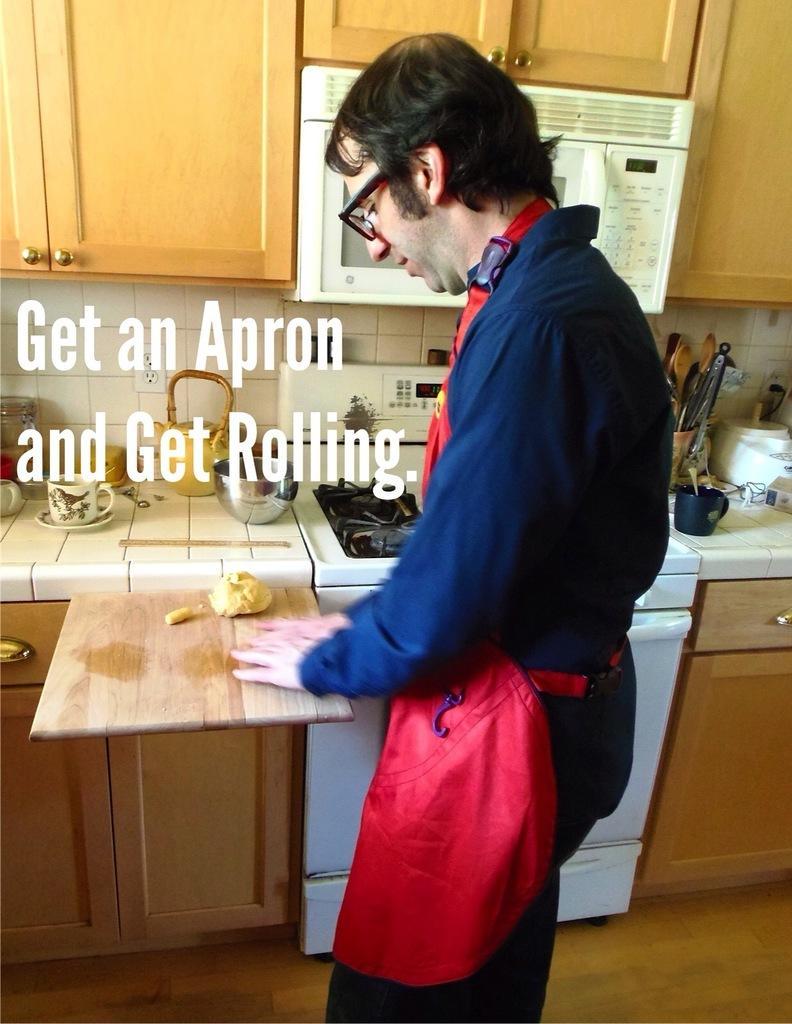Describe this image in one or two sentences. In this picture there is a man in the center of the image, he is wearing apron and there is a chopping pad in front of him and there is a desk and a stove behind him and there are utensils, spoons, and other kitchenware on the desk, there is a oven at the top side of the image, there are cupboards at the top and bottom side of the image. 